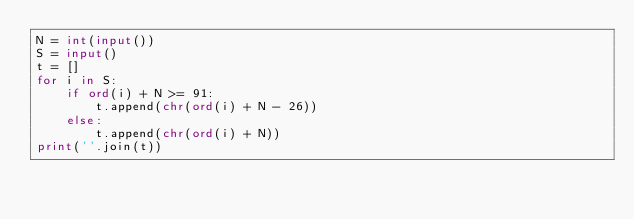<code> <loc_0><loc_0><loc_500><loc_500><_Python_>N = int(input())
S = input()
t = []
for i in S:
    if ord(i) + N >= 91:
        t.append(chr(ord(i) + N - 26))
    else:
        t.append(chr(ord(i) + N))
print(''.join(t))</code> 